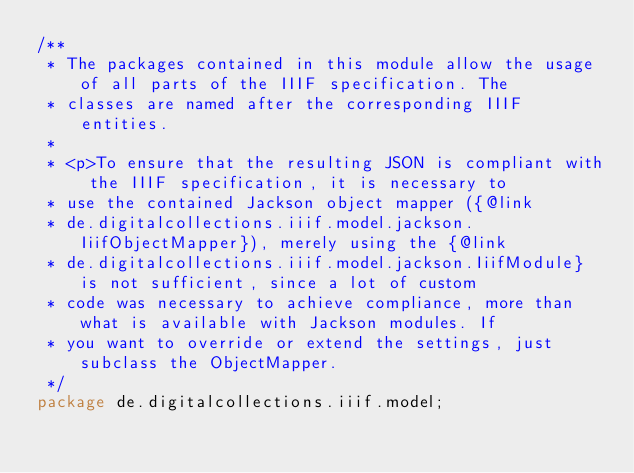Convert code to text. <code><loc_0><loc_0><loc_500><loc_500><_Java_>/**
 * The packages contained in this module allow the usage of all parts of the IIIF specification. The
 * classes are named after the corresponding IIIF entities.
 *
 * <p>To ensure that the resulting JSON is compliant with the IIIF specification, it is necessary to
 * use the contained Jackson object mapper ({@link
 * de.digitalcollections.iiif.model.jackson.IiifObjectMapper}), merely using the {@link
 * de.digitalcollections.iiif.model.jackson.IiifModule} is not sufficient, since a lot of custom
 * code was necessary to achieve compliance, more than what is available with Jackson modules. If
 * you want to override or extend the settings, just subclass the ObjectMapper.
 */
package de.digitalcollections.iiif.model;
</code> 